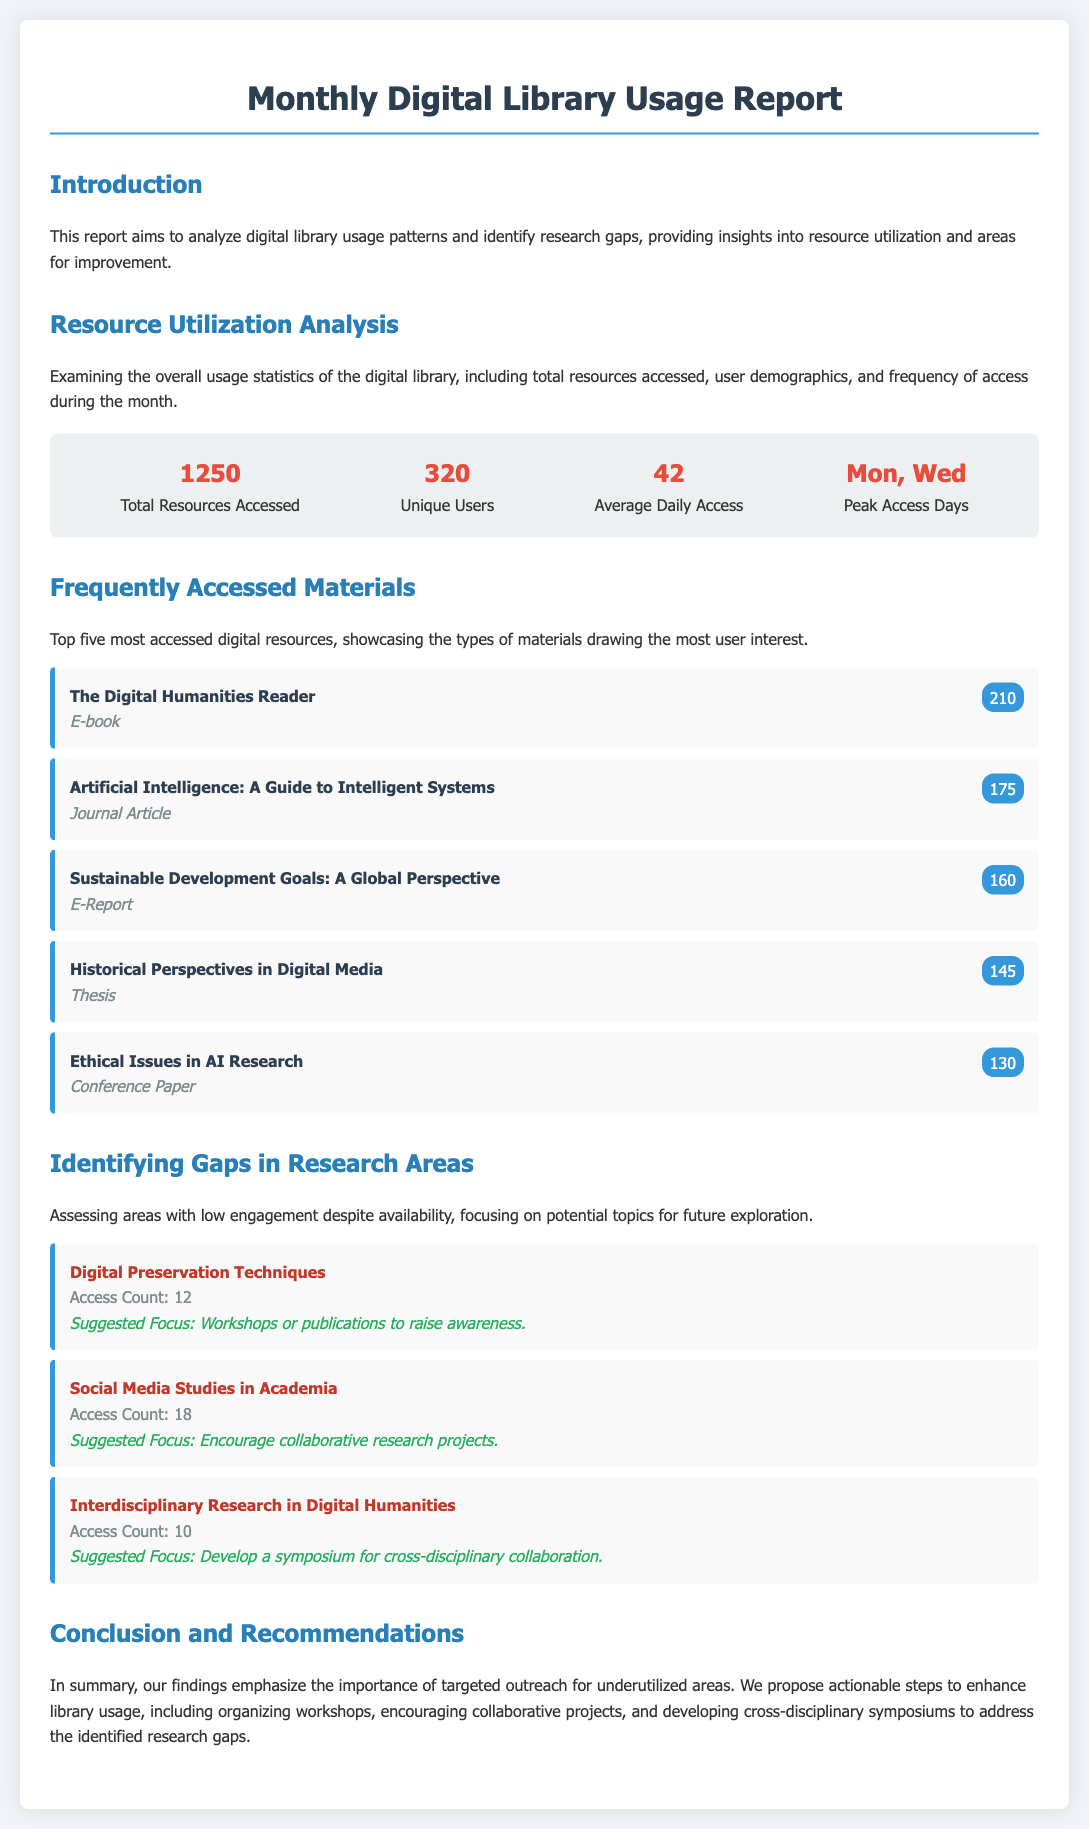What is the total number of resources accessed? The total number of resources accessed is mentioned in the stats section, which states 1250.
Answer: 1250 How many unique users utilized the digital library? The number of unique users is also listed in the statistics, indicating 320 unique users.
Answer: 320 What is the average daily access of the digital library? This information is provided in the resource utilization analysis, which shows an average of 42 daily accesses.
Answer: 42 Which day had peak access in the month? The report specifies that the peak access days were Monday and Wednesday.
Answer: Mon, Wed What is the access count for "Digital Preservation Techniques"? The gap analysis section states that the access count for this topic is 12.
Answer: 12 What is the suggested focus for the area of "Social Media Studies in Academia"? The document suggests encouraging collaborative research projects as a focus for this area.
Answer: Encourage collaborative research projects How many materials are listed in the frequently accessed materials section? The report features a list of the top five most accessed digital resources.
Answer: Five Which type of document was accessed the most? The most accessed resource, "The Digital Humanities Reader," is identified as an E-book.
Answer: E-book What conclusion is drawn regarding underutilized areas? The conclusion emphasizes the importance of targeted outreach for underutilized areas.
Answer: Targeted outreach for underutilized areas 